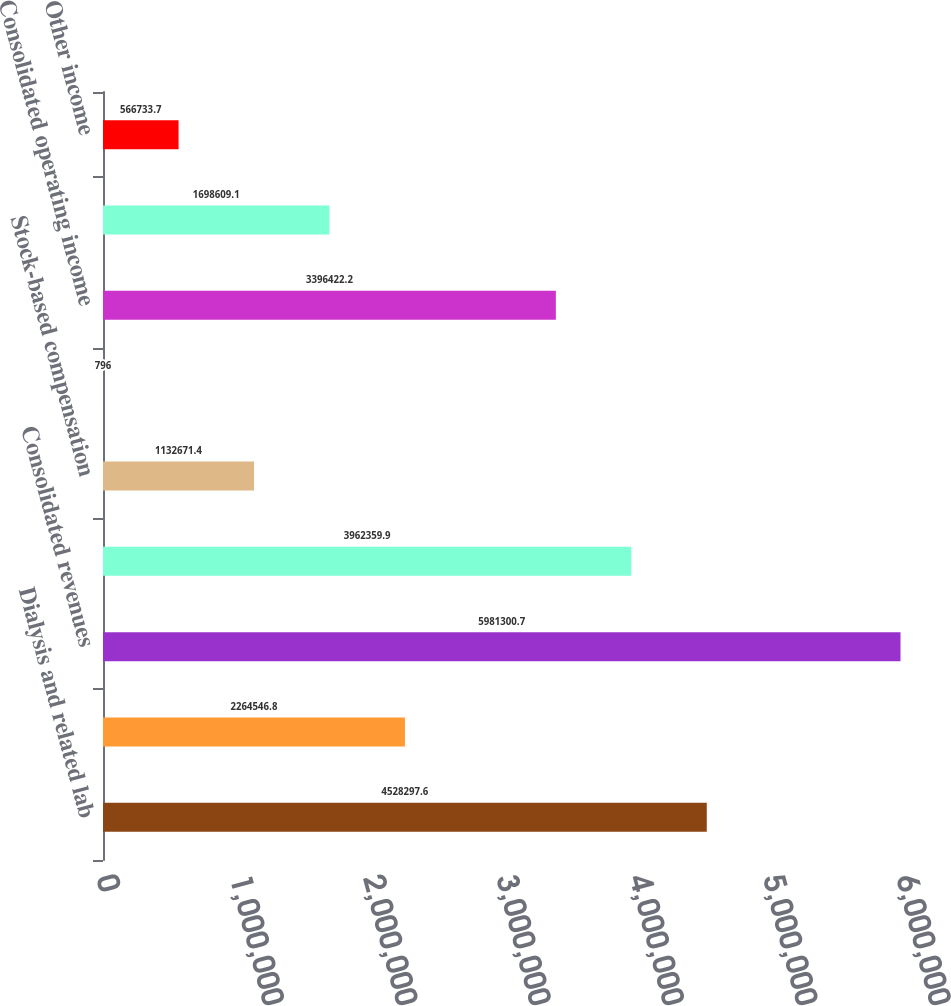<chart> <loc_0><loc_0><loc_500><loc_500><bar_chart><fcel>Dialysis and related lab<fcel>Other-Ancillary services and<fcel>Consolidated revenues<fcel>Total segment margin<fcel>Stock-based compensation<fcel>Equity investment income<fcel>Consolidated operating income<fcel>Debt expense<fcel>Other income<nl><fcel>4.5283e+06<fcel>2.26455e+06<fcel>5.9813e+06<fcel>3.96236e+06<fcel>1.13267e+06<fcel>796<fcel>3.39642e+06<fcel>1.69861e+06<fcel>566734<nl></chart> 